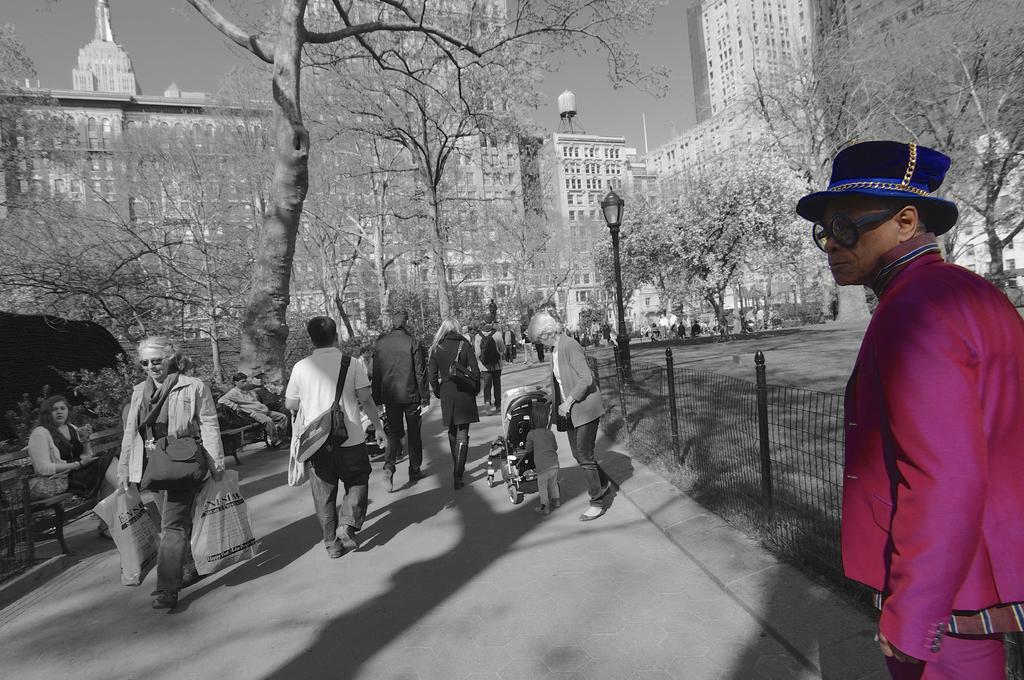Describe this image in one or two sentences. This is an edited image. On the right side of this image there is a man wearing a pink color jacket, blue color cap on the head and looking at the right side. The background is in black and white colors. On the left side few people are walking on the road. Beside the road there is a fencing and few people are sitting on the benches. In the background there are many trees, buildings and light poles. At the top of the image I can see the sky. 